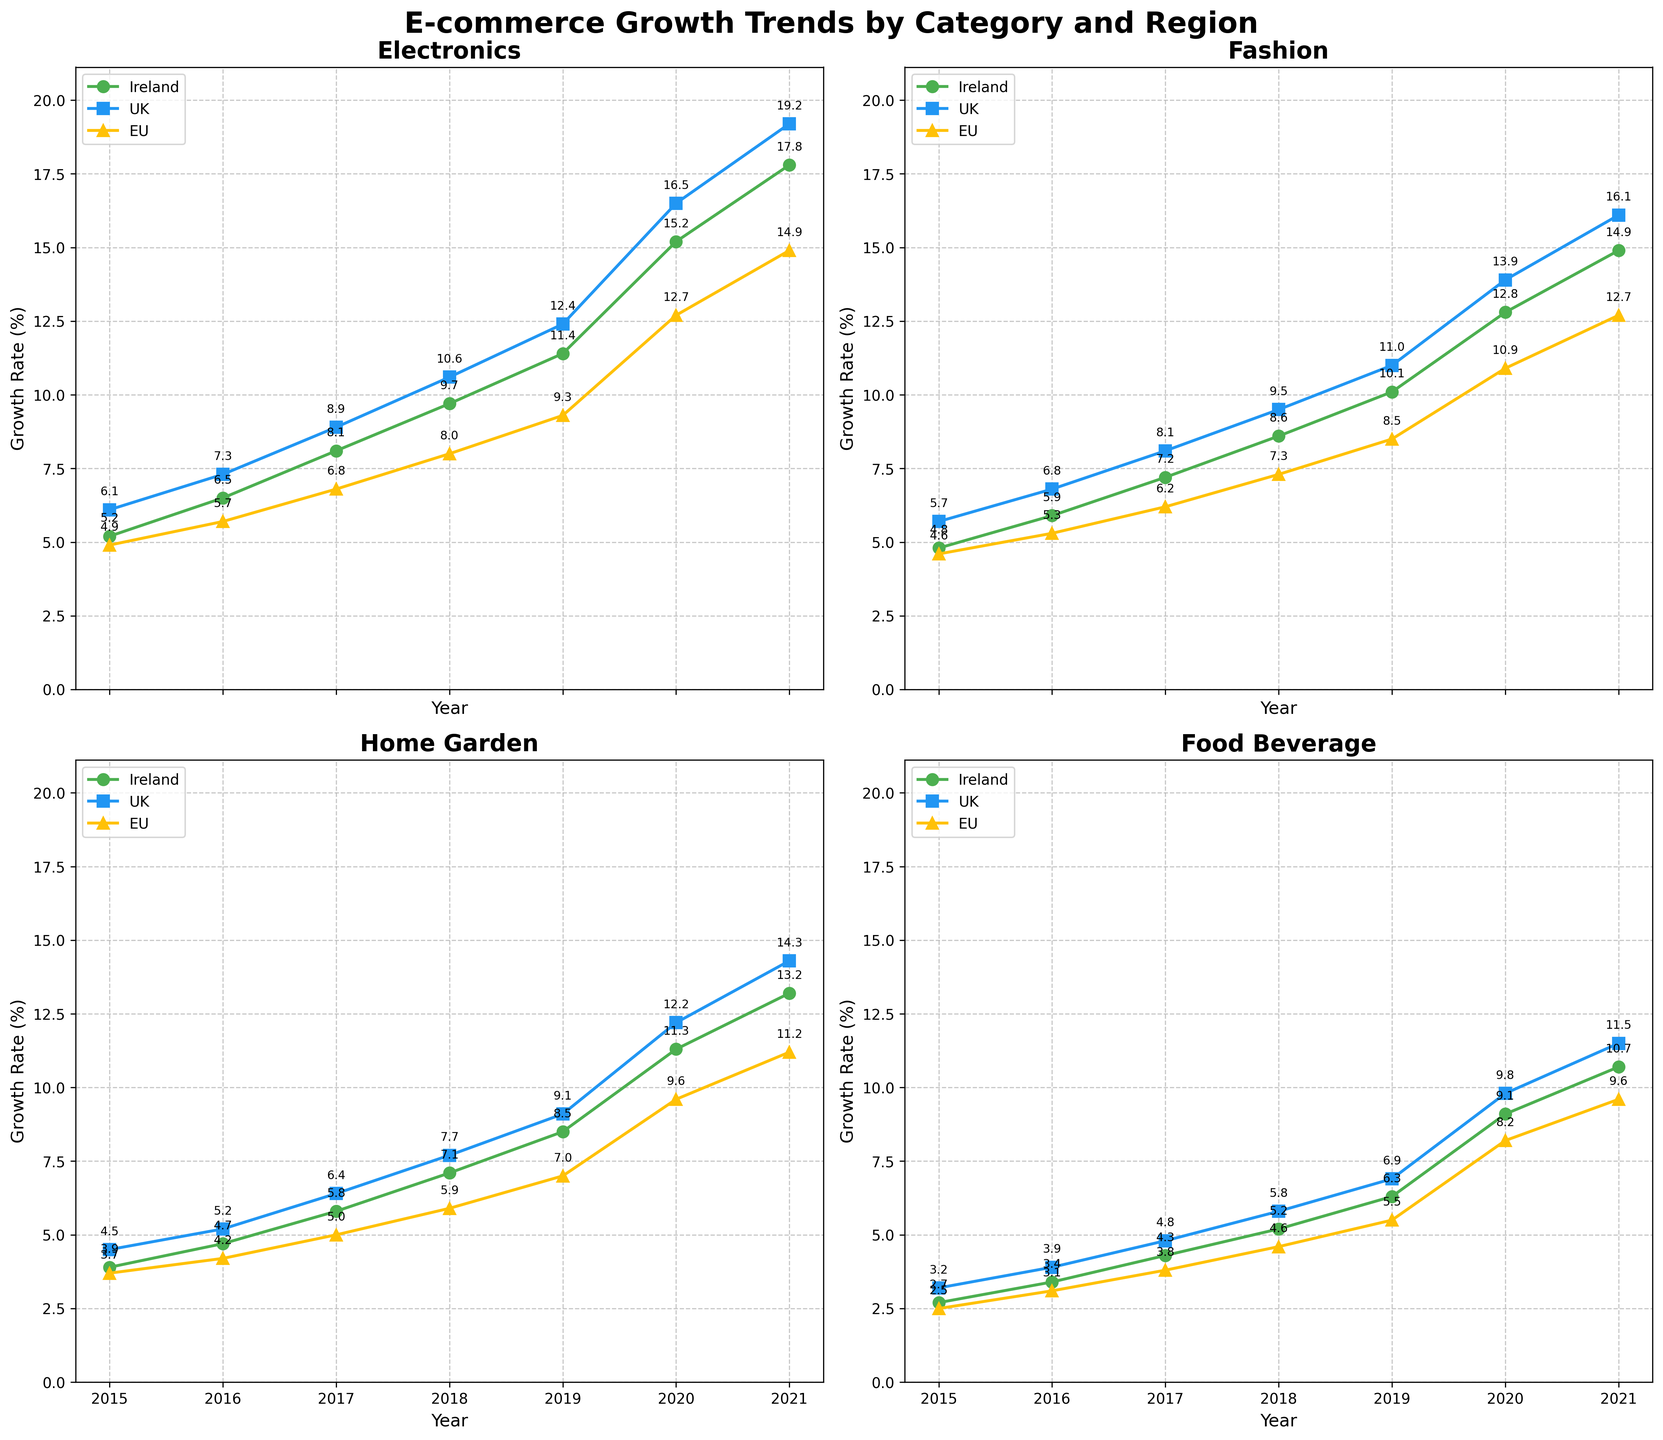Which region had the highest growth rate in Electronics in 2021? Look at the line plot for the Electronics category and find the highest point for 2021. The peak growth rate percentage in this year belongs to the UK.
Answer: UK How did the Food & Beverage growth rate in Ireland change from 2015 to 2021? Locate the points for Food & Beverage in Ireland in both years and note the growth rates. Subtract the earlier value (2.7%) from the later value (10.7%).
Answer: Increase of 8% Which product category saw the largest increase in growth rate in the EU from 2015 to 2021? Check the line plots for each category in the EU. Note the growth rate changes from 2015 to 2021. Find the largest change by subtracting the 2015 values from the 2021 values for each category. The largest difference is in Electronics.
Answer: Electronics Compare the growth rate trends for Fashion in Ireland and the UK between 2015 and 2021. Observe the slopes of the Fashion line plots for Ireland and the UK over this time span. Both show upward trends, but the UK's growth consistently surpasses Ireland's throughout these years.
Answer: UK's trend is higher In which year did the Home & Garden sector in the UK experience the sharpest increase in growth rate? Look at the slope of the Home & Garden line plot for the UK and identify the year with the steepest upward slope. 2017 to 2018 shows the largest increase.
Answer: 2017 to 2018 By how much did the Electronics growth rate in the EU increase from 2018 to 2021? Find the growth rates in 2018 and 2021 for EU Electronics. Subtract the 2018 value (8%) from the 2021 value (14.9%).
Answer: 6.9% Which category had the closest growth rates in 2020 across all three regions? Compare the growth rates for each category in 2020 across Ireland, UK, and EU. The total comparison shows Home & Garden had quite similar rates.
Answer: Home & Garden What was the average yearly growth rate for Fashion in the UK from 2015 to 2021? Sum up the yearly growth rates for Fashion in the UK (5.7, 6.8, 8.1, 9.5, 11.0, 13.9, 16.1) and then divide by the number of years (7). Calculation is (5.7 + 6.8 + 8.1 + 9.5 + 11.0 + 13.9 + 16.1) /7.
Answer: 10.16% How many times did the Food & Beverage category experience a growth rate of over 10% in Ireland from 2015 to 2021? Check the Food & Beverage growth rates for Ireland from 2015 to 2021. Identify instances where the values are greater than 10%. There are two such occurrences, in 2020 and 2021.
Answer: 2 times 